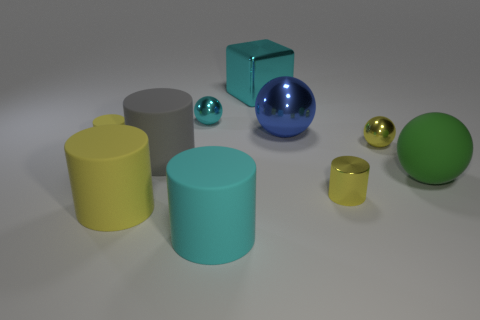Subtract all yellow cylinders. How many were subtracted if there are1yellow cylinders left? 2 Subtract all yellow blocks. How many yellow cylinders are left? 3 Subtract all yellow balls. How many balls are left? 3 Subtract 2 spheres. How many spheres are left? 2 Subtract all gray cylinders. How many cylinders are left? 4 Subtract all balls. How many objects are left? 6 Subtract all matte blocks. Subtract all green balls. How many objects are left? 9 Add 9 big blue things. How many big blue things are left? 10 Add 5 big cyan cylinders. How many big cyan cylinders exist? 6 Subtract 1 yellow cylinders. How many objects are left? 9 